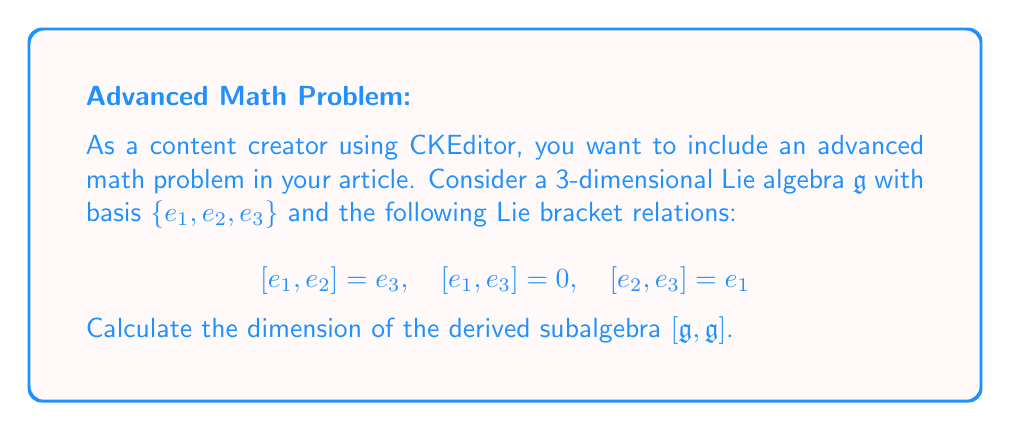Provide a solution to this math problem. To calculate the dimension of the derived subalgebra $[\mathfrak{g}, \mathfrak{g}]$, we need to follow these steps:

1) The derived subalgebra $[\mathfrak{g}, \mathfrak{g}]$ is the subspace of $\mathfrak{g}$ spanned by all Lie brackets $[x, y]$ where $x, y \in \mathfrak{g}$.

2) We need to consider all possible brackets of basis elements:

   $[e_1, e_2] = e_3$
   $[e_1, e_3] = 0$
   $[e_2, e_3] = e_1$
   $[e_2, e_1] = -e_3$ (using antisymmetry of the Lie bracket)
   $[e_3, e_1] = 0$
   $[e_3, e_2] = -e_1$

3) We see that $[\mathfrak{g}, \mathfrak{g}]$ is spanned by $\{e_1, e_3\}$.

4) To confirm that these vectors are linearly independent, we can check that neither is a scalar multiple of the other.

5) Since we have two linearly independent vectors spanning $[\mathfrak{g}, \mathfrak{g}]$, the dimension of $[\mathfrak{g}, \mathfrak{g}]$ is 2.

This result shows that the derived subalgebra is a proper subspace of $\mathfrak{g}$, as its dimension is less than that of $\mathfrak{g}$.
Answer: The dimension of the derived subalgebra $[\mathfrak{g}, \mathfrak{g}]$ is 2. 